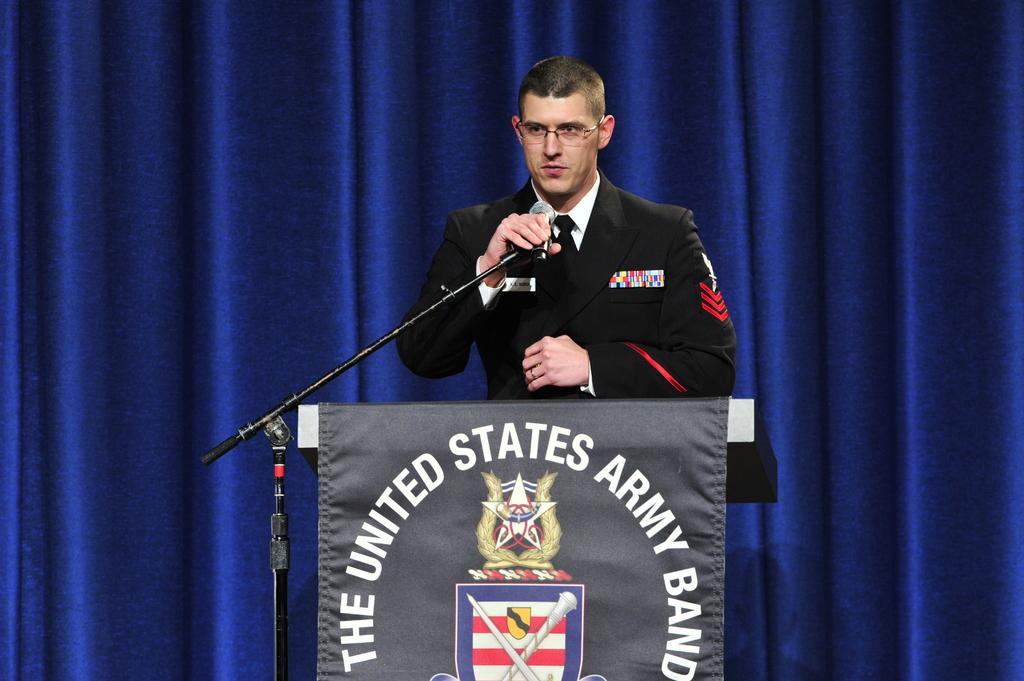Provide a one-sentence caption for the provided image. A man wearing military uniform, standing at a podium that is draped with "The United States Army Band" logo in the front. 